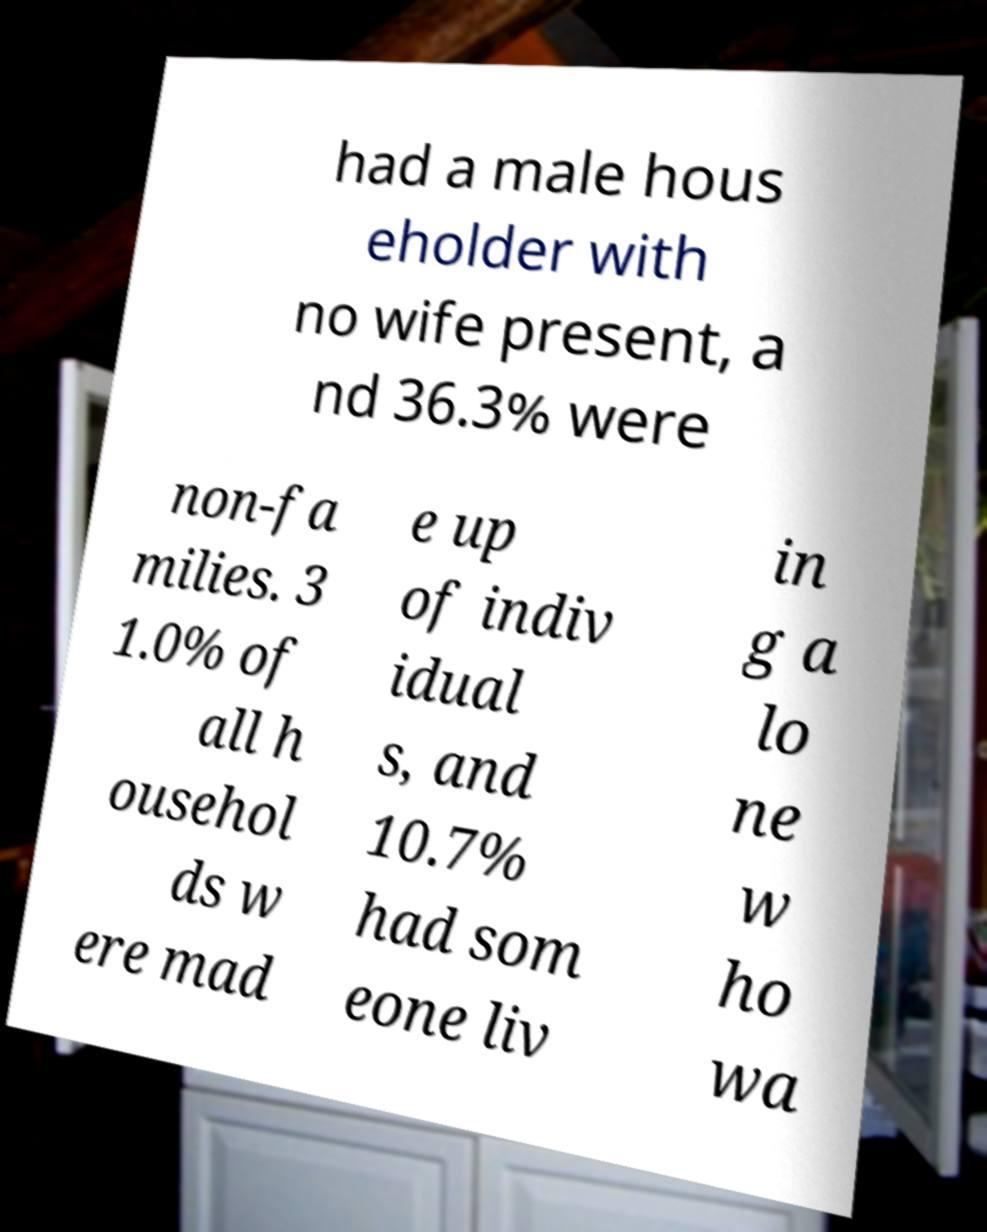Can you read and provide the text displayed in the image?This photo seems to have some interesting text. Can you extract and type it out for me? had a male hous eholder with no wife present, a nd 36.3% were non-fa milies. 3 1.0% of all h ousehol ds w ere mad e up of indiv idual s, and 10.7% had som eone liv in g a lo ne w ho wa 